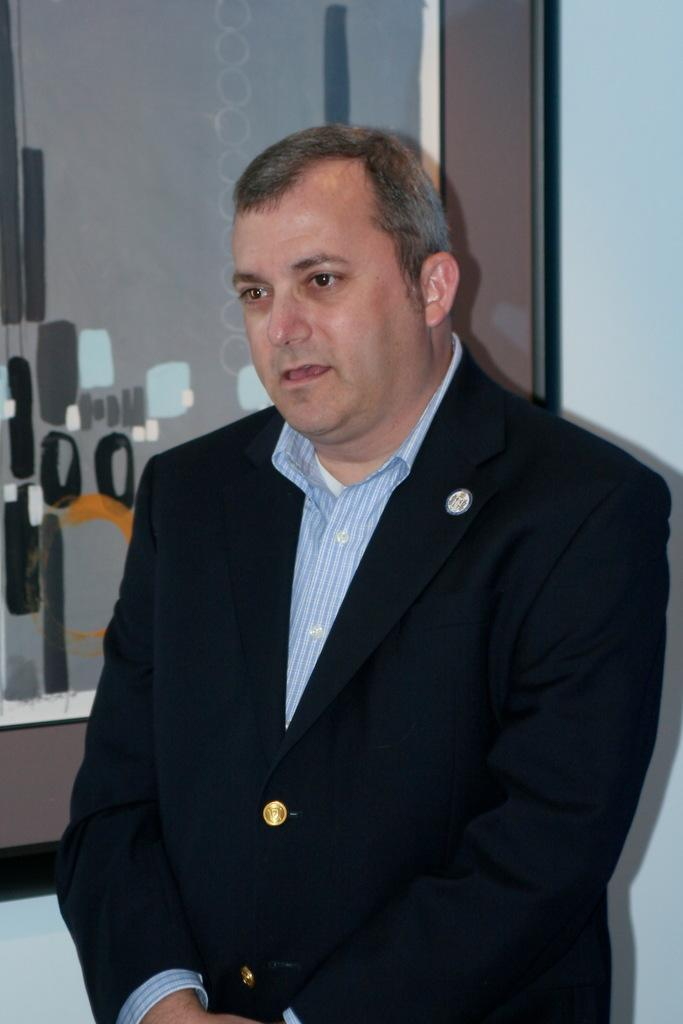Who is present in the image? There is a man in the image. What is the man wearing? The man is wearing a black suit. What can be seen in the background of the image? There is a wall in the background of the image. What type of eggnog is the man holding in the image? There is no eggnog present in the image; the man is not holding anything. How does the soap in the image affect the man's appearance? There is no soap present in the image, so it cannot affect the man's appearance. 